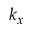Convert formula to latex. <formula><loc_0><loc_0><loc_500><loc_500>k _ { x }</formula> 